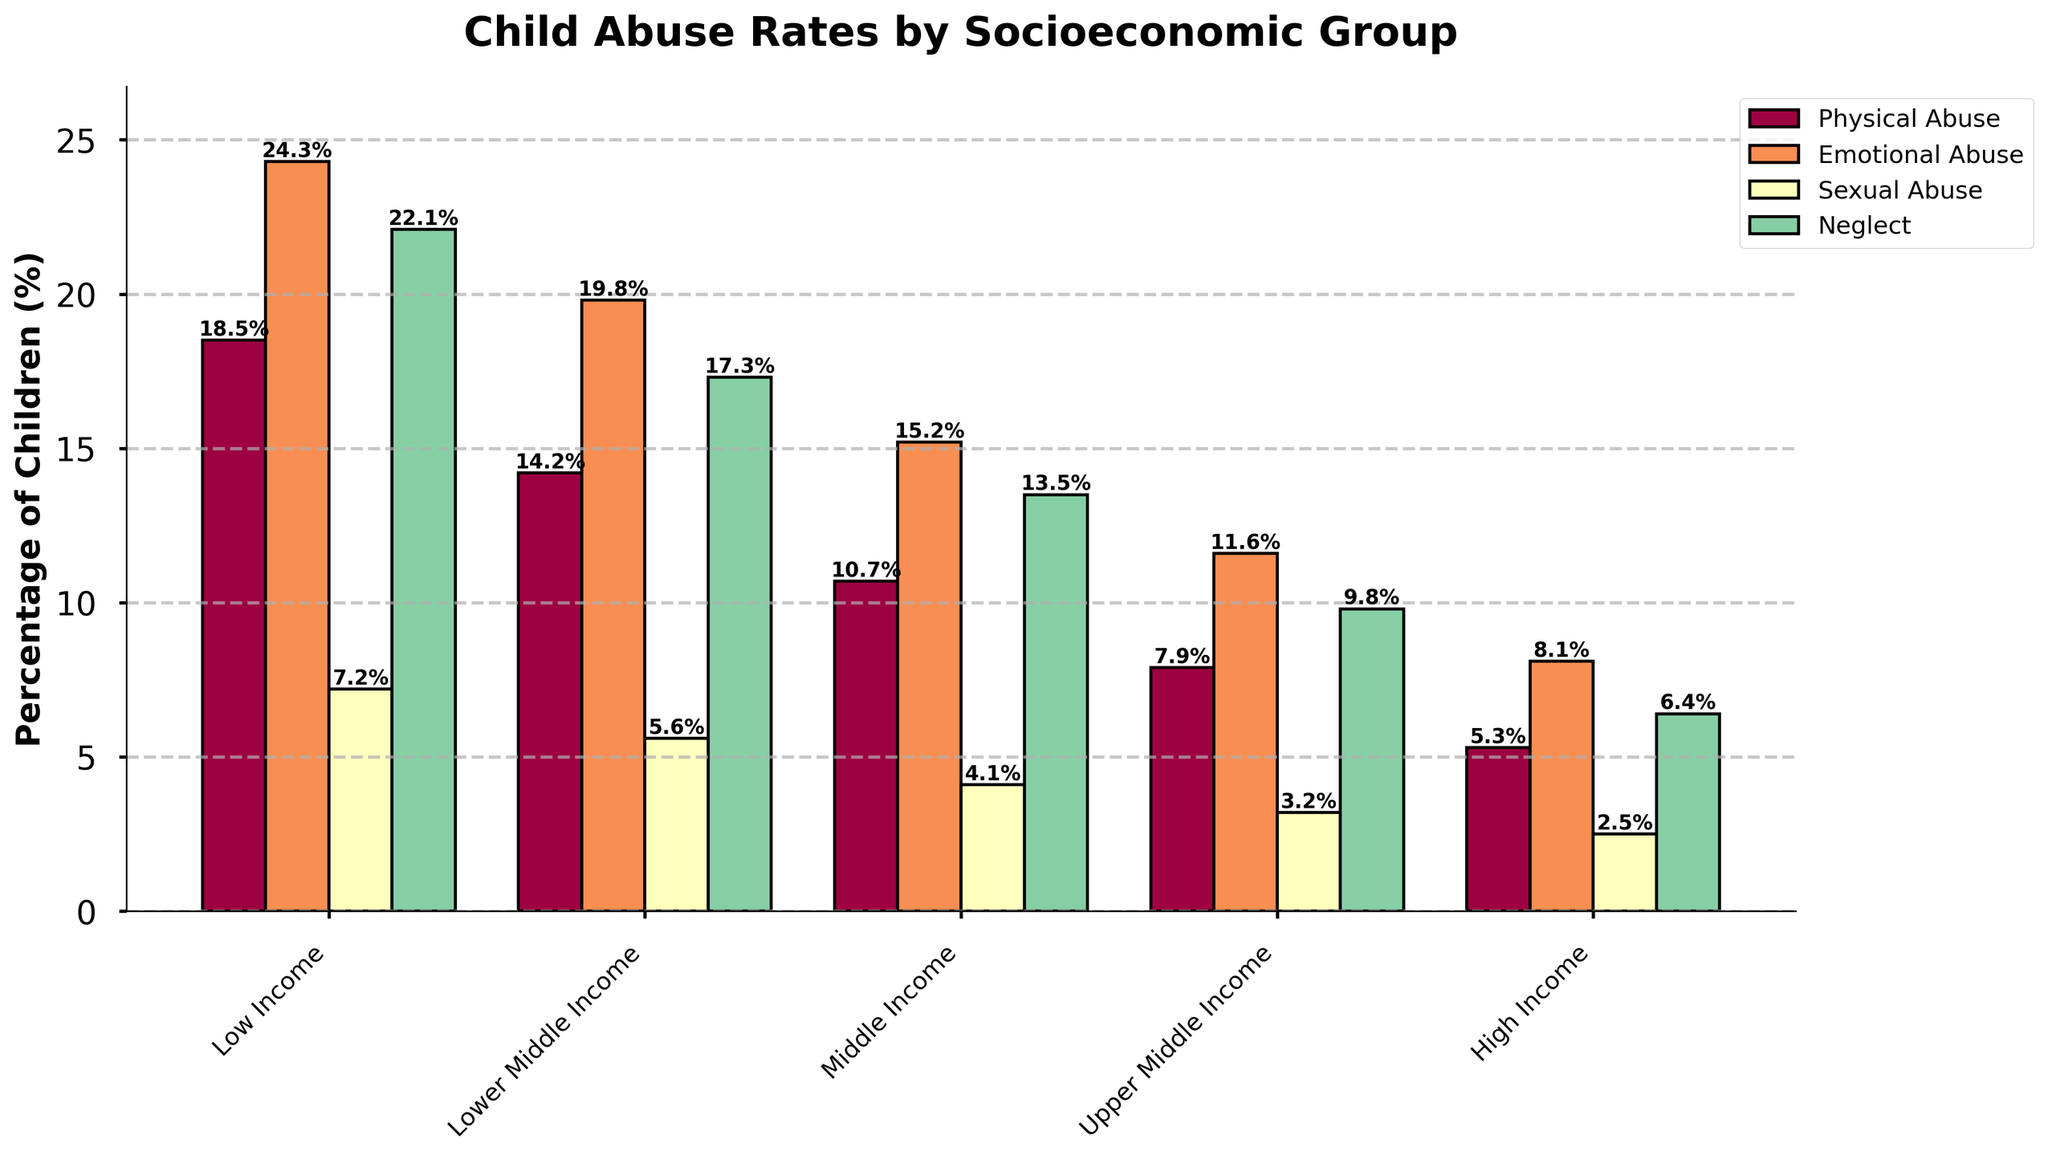Which socioeconomic group has the highest percentage of children experiencing emotional abuse? The figure shows that the high-income group has the lowest emotional abuse rate, while the low-income group has the highest.
Answer: Low Income What is the difference in the percentage of physical abuse between the low-income and high-income groups? The figure shows that physical abuse is 18.5% for low-income and 5.3% for high-income groups. The difference is 18.5% - 5.3%.
Answer: 13.2% Which form of abuse has the smallest percentage disparity between the low-income and high-income groups? The figure shows the percentage values for each form of abuse in both low-income and high-income. Calculate the percentage differences: Physical (18.5% - 5.3%), Emotional (24.3% - 8.1%), Sexual (7.2% - 2.5%) and Neglect (22.1% - 6.4%). The smallest is for Sexual (4.7%).
Answer: Sexual Abuse How does the percentage of children experiencing sexual abuse in the middle-income group compare to the upper middle-income group? The figure shows the bars for both groups: 4.1% for middle-income and 3.2% for upper middle-income. Middle-income is higher by 0.9%.
Answer: Middle Income is higher What is the total percentage of children experiencing neglect across all socioeconomic groups? Sum the percentages of neglect from all groups: 22.1% + 17.3% + 13.5% + 9.8% + 6.4%. The total is 69.1%.
Answer: 69.1% In which socioeconomic group is the percentage of emotional abuse more than double the percentage of sexual abuse? Compare the percentages of emotional and sexual abuse in each group: Low Income (24.3% vs. 7.2%), Lower Middle Income (19.8% vs. 5.6%), Middle Income (15.2% vs. 4.1%), Upper Middle Income (11.6% vs. 3.2%), High Income (8.1% vs. 2.5%). In each case, the percentage of emotional abuse is more than double the percentage of sexual abuse.
Answer: All groups In which socioeconomic group is the percentage of physical abuse closest to the percentage of neglect? Compare the percentages of physical abuse and neglect in each group: Low Income (18.5% vs. 22.1%), Lower Middle Income (14.2% vs. 17.3%), Middle Income (10.7% vs. 13.5%), Upper Middle Income (7.9% vs. 9.8%), High Income (5.3% vs. 6.4%). The closest difference is in High Income, which is 1.1%.
Answer: High Income 